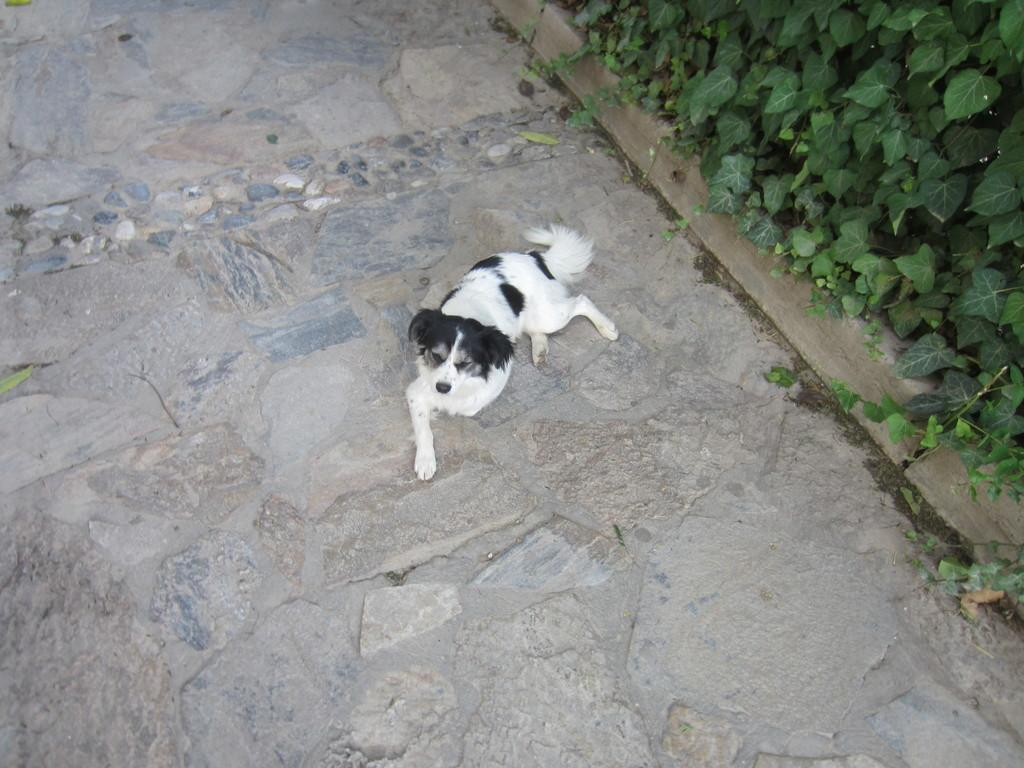What type of animal is in the image? There is a dog in the image. Where is the dog located? The dog is on the ground. What can be seen in the background of the image? There are trees in the background of the image. What type of yoke can be seen on the dog in the image? There is no yoke present on the dog in the image. How does the dog create a wave in the image? The dog does not create a wave in the image; it is simply sitting or standing on the ground. 